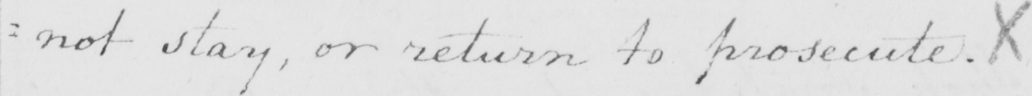What does this handwritten line say? : not stay , or return to prosecute . X 